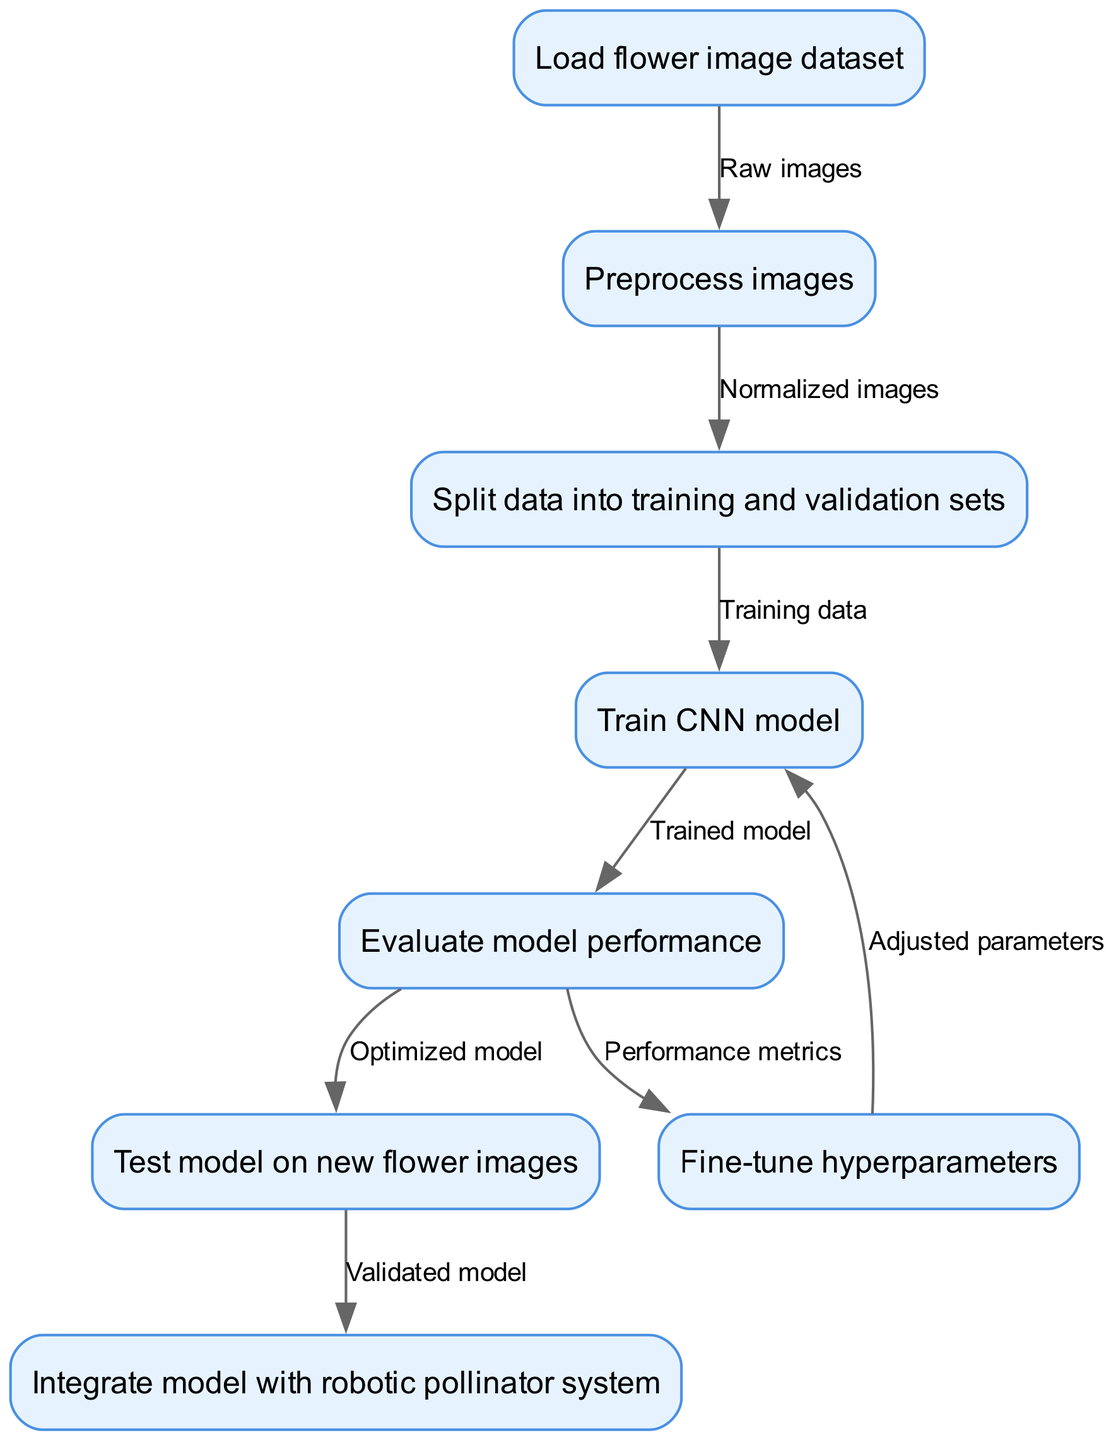What is the first step in the machine learning model training process? The first step is "Load flower image dataset." This can be determined by looking at the starting node in the flowchart, which indicates the beginning of the process.
Answer: Load flower image dataset How many nodes are in the diagram? To find the number of nodes, we can count each unique box in the diagram. There are eight defined steps in the training process, corresponding to the nodes.
Answer: Eight What does the edge between "Preprocess images" and "Split data into training and validation sets" represent? The edge signifies that the output of the "Preprocess images" node, which produces normalized images, is passed to the next step "Split data into training and validation sets." This illustrates the flow of the process from one step to the next.
Answer: Normalized images What is the final step in the training process? The last node in the flowchart is "Integrate model with robotic pollinator system." This is identified by locating the last step that follows the workflow indicated by the edges.
Answer: Integrate model with robotic pollinator system How many edges are there in the diagram? The total number of edges can be counted by reviewing the connections drawn between nodes. There are seven edges indicating the flow of the process.
Answer: Seven What must be done after evaluating the model performance? After evaluating the model performance, the next step is to "Fine-tune hyperparameters." This can be seen by following the edge that stems from the "Evaluate model performance" node.
Answer: Fine-tune hyperparameters What step comes after training the CNN model? After the step "Train CNN model," the subsequent step is "Evaluate model performance." This is dictated by the directed edge leading from training to evaluation in the flowchart.
Answer: Evaluate model performance Which step involves testing the model on new flower images? The step for testing the model is "Test model on new flower images." This is verified by tracing the flow from the optimized model to this testing stage.
Answer: Test model on new flower images 